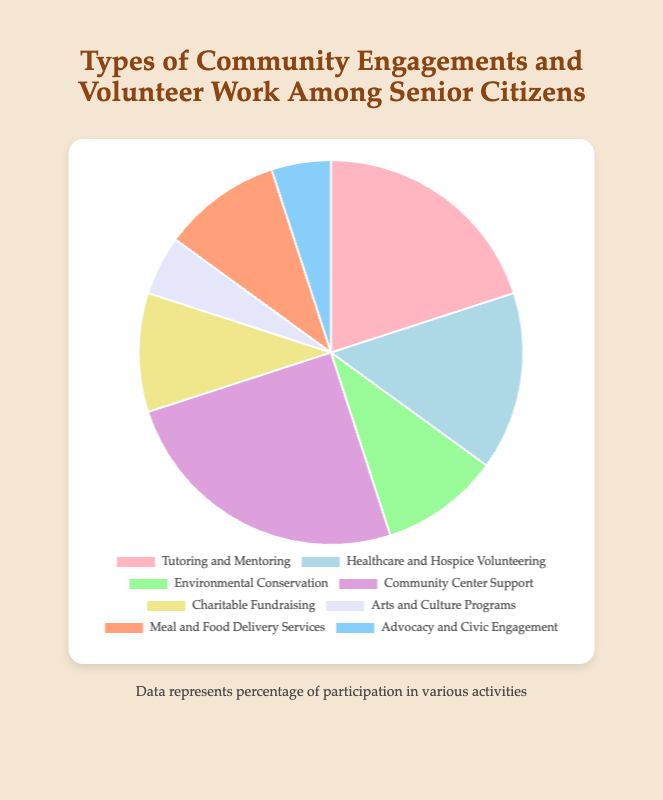What is the total percentage for Healthcare and Hospice Volunteering and Environmental Conservation? To find the total percentage for Healthcare and Hospice Volunteering and Environmental Conservation, add their individual percentages: 15% (Healthcare) + 10% (Environmental) = 25%
Answer: 25% Which type of community engagement has the highest participation percentage among senior citizens? Look for the type with the largest share in the pie chart. Community Center Support has the largest slice at 25%.
Answer: Community Center Support Are there more senior citizens involved in Tutoring and Mentoring or Charitable Fundraising? Compare the percentages for Tutoring and Mentoring (20%) and Charitable Fundraising (10%). 20% is greater than 10%.
Answer: Tutoring and Mentoring Which two types of engagement have the least percentage and what is their combined total? Identify the types with the smallest percentages: Arts and Culture Programs (5%) and Advocacy and Civic Engagement (5%). Their combined total is 5% + 5% = 10%.
Answer: Arts and Culture Programs and Advocacy and Civic Engagement; 10% What is the percentage difference between Meal and Food Delivery Services and Healthcare and Hospice Volunteering? Calculate the difference between the percentages for Meal and Food Delivery Services (10%) and Healthcare and Hospice Volunteering (15%): 15% - 10% = 5%
Answer: 5% What is the average percentage of all volunteer types listed in the chart? Add up all the percentages and divide by the number of types. (20% + 15% + 10% + 25% + 10% + 5% + 10% + 5%) / 8 = 100% / 8 = 12.5%
Answer: 12.5% Which activities have exactly the same participation percentage? Look for activities with the same percentage in the pie chart. Arts and Culture Programs and Advocacy and Civic Engagement both have 5%.
Answer: Arts and Culture Programs and Advocacy and Civic Engagement By how much does Healthcare and Hospice Volunteering exceed Arts and Culture Programs in terms of participation percentage? Subtract the percentage for Arts and Culture Programs (5%) from Healthcare and Hospice Volunteering (15%): 15% - 5% = 10%
Answer: 10% What percentage of senior citizens engages in Charitable Fundraising and Meal and Food Delivery Services combined? Add the percentages for Charitable Fundraising (10%) and Meal and Food Delivery Services (10%): 10% + 10% = 20%
Answer: 20% 